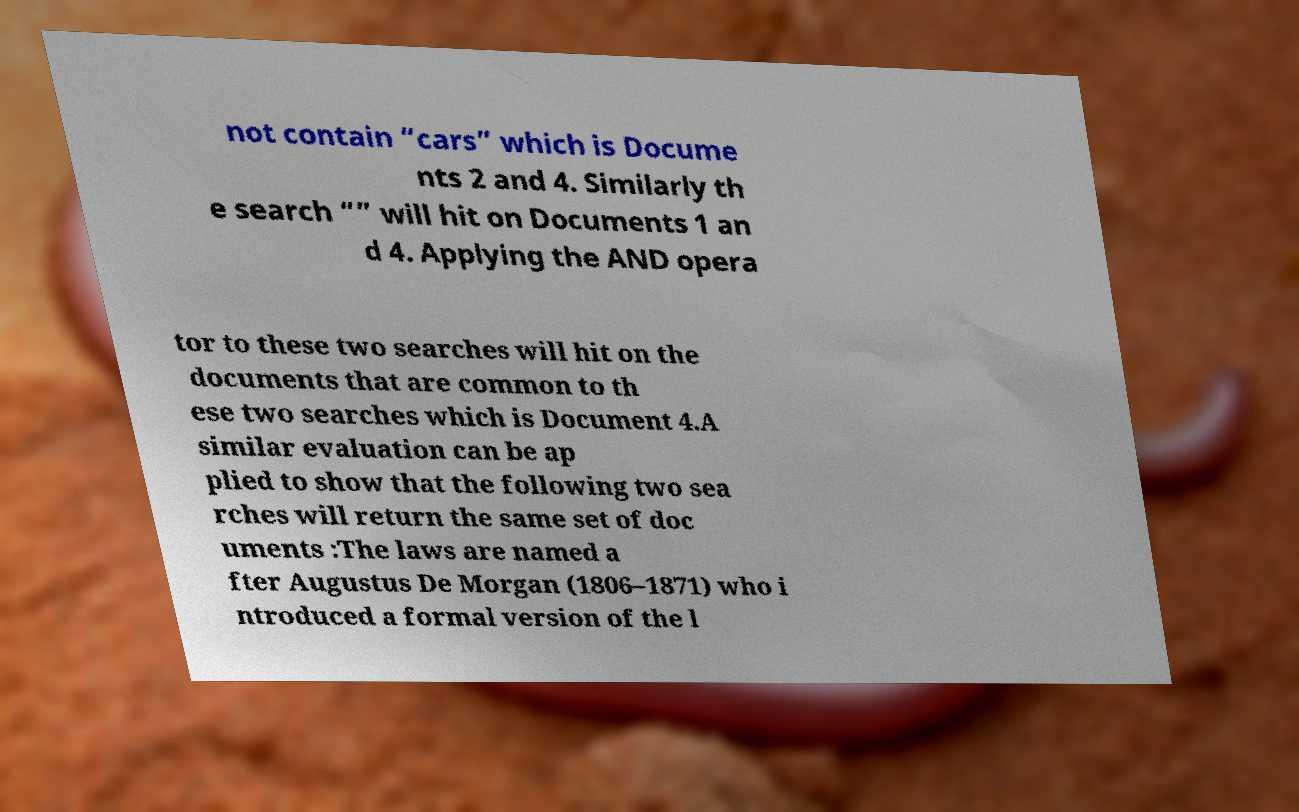What messages or text are displayed in this image? I need them in a readable, typed format. not contain “cars” which is Docume nts 2 and 4. Similarly th e search “” will hit on Documents 1 an d 4. Applying the AND opera tor to these two searches will hit on the documents that are common to th ese two searches which is Document 4.A similar evaluation can be ap plied to show that the following two sea rches will return the same set of doc uments :The laws are named a fter Augustus De Morgan (1806–1871) who i ntroduced a formal version of the l 